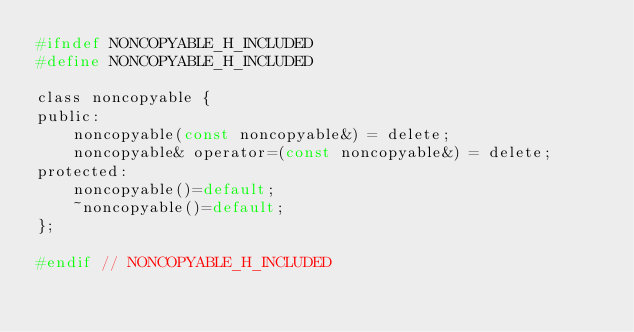<code> <loc_0><loc_0><loc_500><loc_500><_C_>#ifndef NONCOPYABLE_H_INCLUDED
#define NONCOPYABLE_H_INCLUDED

class noncopyable {
public:
    noncopyable(const noncopyable&) = delete;
    noncopyable& operator=(const noncopyable&) = delete;
protected:
    noncopyable()=default;
    ~noncopyable()=default;
};

#endif // NONCOPYABLE_H_INCLUDED
</code> 